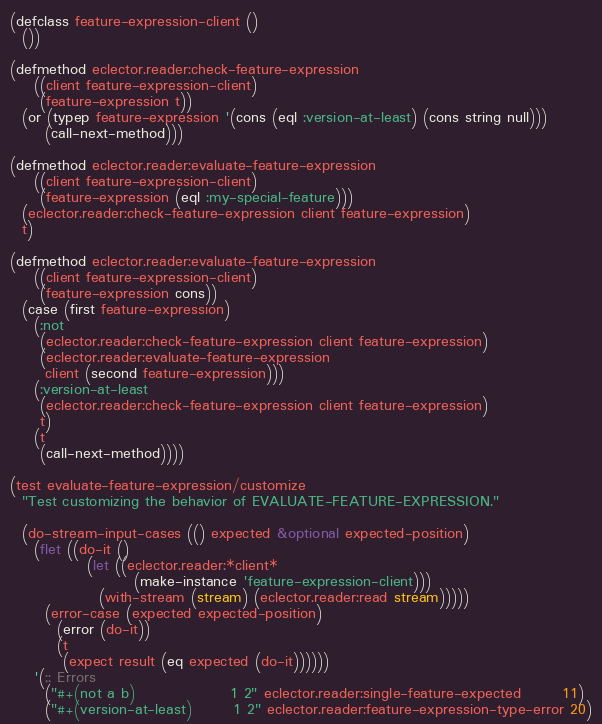Convert code to text. <code><loc_0><loc_0><loc_500><loc_500><_Lisp_>
(defclass feature-expression-client ()
  ())

(defmethod eclector.reader:check-feature-expression
    ((client feature-expression-client)
     (feature-expression t))
  (or (typep feature-expression '(cons (eql :version-at-least) (cons string null)))
      (call-next-method)))

(defmethod eclector.reader:evaluate-feature-expression
    ((client feature-expression-client)
     (feature-expression (eql :my-special-feature)))
  (eclector.reader:check-feature-expression client feature-expression)
  t)

(defmethod eclector.reader:evaluate-feature-expression
    ((client feature-expression-client)
     (feature-expression cons))
  (case (first feature-expression)
    (:not
     (eclector.reader:check-feature-expression client feature-expression)
     (eclector.reader:evaluate-feature-expression
      client (second feature-expression)))
    (:version-at-least
     (eclector.reader:check-feature-expression client feature-expression)
     t)
    (t
     (call-next-method))))

(test evaluate-feature-expression/customize
  "Test customizing the behavior of EVALUATE-FEATURE-EXPRESSION."

  (do-stream-input-cases (() expected &optional expected-position)
    (flet ((do-it ()
             (let ((eclector.reader:*client*
                     (make-instance 'feature-expression-client)))
               (with-stream (stream) (eclector.reader:read stream)))))
      (error-case (expected expected-position)
        (error (do-it))
        (t
         (expect result (eq expected (do-it))))))
    '(;; Errors
      ("#+(not a b)                1 2" eclector.reader:single-feature-expected       11)
      ("#+(version-at-least)       1 2" eclector.reader:feature-expression-type-error 20)</code> 